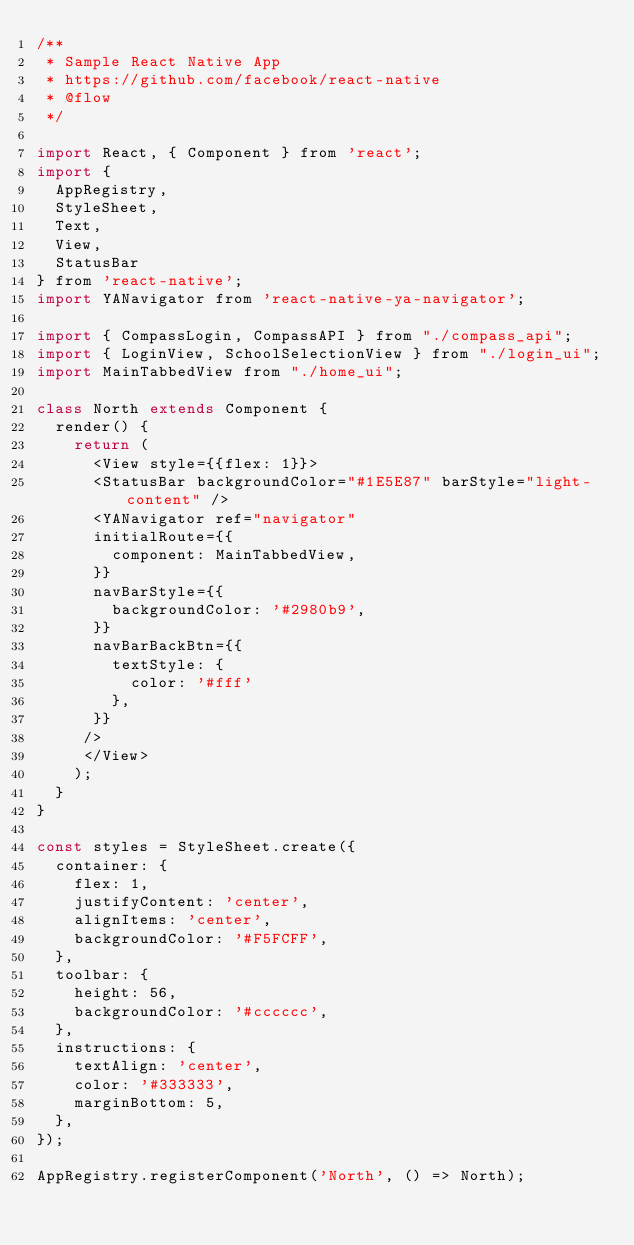Convert code to text. <code><loc_0><loc_0><loc_500><loc_500><_JavaScript_>/**
 * Sample React Native App
 * https://github.com/facebook/react-native
 * @flow
 */

import React, { Component } from 'react';
import {
  AppRegistry,
  StyleSheet,
  Text,
  View,
  StatusBar
} from 'react-native';
import YANavigator from 'react-native-ya-navigator';

import { CompassLogin, CompassAPI } from "./compass_api";
import { LoginView, SchoolSelectionView } from "./login_ui";
import MainTabbedView from "./home_ui";

class North extends Component {
  render() {
    return (
      <View style={{flex: 1}}>
      <StatusBar backgroundColor="#1E5E87" barStyle="light-content" />
      <YANavigator ref="navigator"
      initialRoute={{
        component: MainTabbedView,
      }}
      navBarStyle={{
        backgroundColor: '#2980b9',
      }}
      navBarBackBtn={{
        textStyle: {
          color: '#fff'
        },
      }}
     />
     </View>
    );
  }
}

const styles = StyleSheet.create({
  container: {
    flex: 1,
    justifyContent: 'center',
    alignItems: 'center',
    backgroundColor: '#F5FCFF',
  },
  toolbar: {
    height: 56,
    backgroundColor: '#cccccc',
  },
  instructions: {
    textAlign: 'center',
    color: '#333333',
    marginBottom: 5,
  },
});

AppRegistry.registerComponent('North', () => North);
</code> 